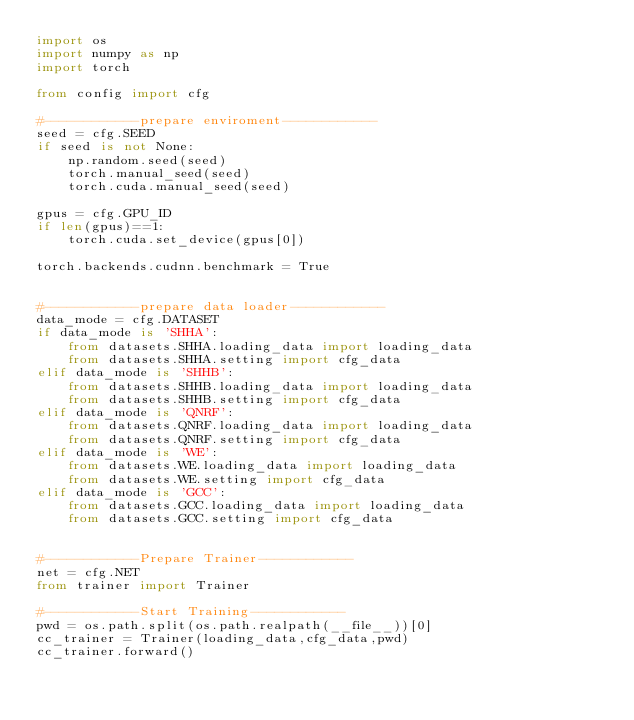<code> <loc_0><loc_0><loc_500><loc_500><_Python_>import os
import numpy as np
import torch

from config import cfg

#------------prepare enviroment------------
seed = cfg.SEED
if seed is not None:
    np.random.seed(seed)
    torch.manual_seed(seed)
    torch.cuda.manual_seed(seed)

gpus = cfg.GPU_ID
if len(gpus)==1:
    torch.cuda.set_device(gpus[0])

torch.backends.cudnn.benchmark = True


#------------prepare data loader------------
data_mode = cfg.DATASET
if data_mode is 'SHHA':
    from datasets.SHHA.loading_data import loading_data 
    from datasets.SHHA.setting import cfg_data 
elif data_mode is 'SHHB':
    from datasets.SHHB.loading_data import loading_data 
    from datasets.SHHB.setting import cfg_data 
elif data_mode is 'QNRF':
    from datasets.QNRF.loading_data import loading_data 
    from datasets.QNRF.setting import cfg_data
elif data_mode is 'WE':
    from datasets.WE.loading_data import loading_data 
    from datasets.WE.setting import cfg_data 
elif data_mode is 'GCC':
    from datasets.GCC.loading_data import loading_data
    from datasets.GCC.setting import cfg_data 


#------------Prepare Trainer------------
net = cfg.NET
from trainer import Trainer

#------------Start Training------------
pwd = os.path.split(os.path.realpath(__file__))[0]
cc_trainer = Trainer(loading_data,cfg_data,pwd)
cc_trainer.forward()</code> 